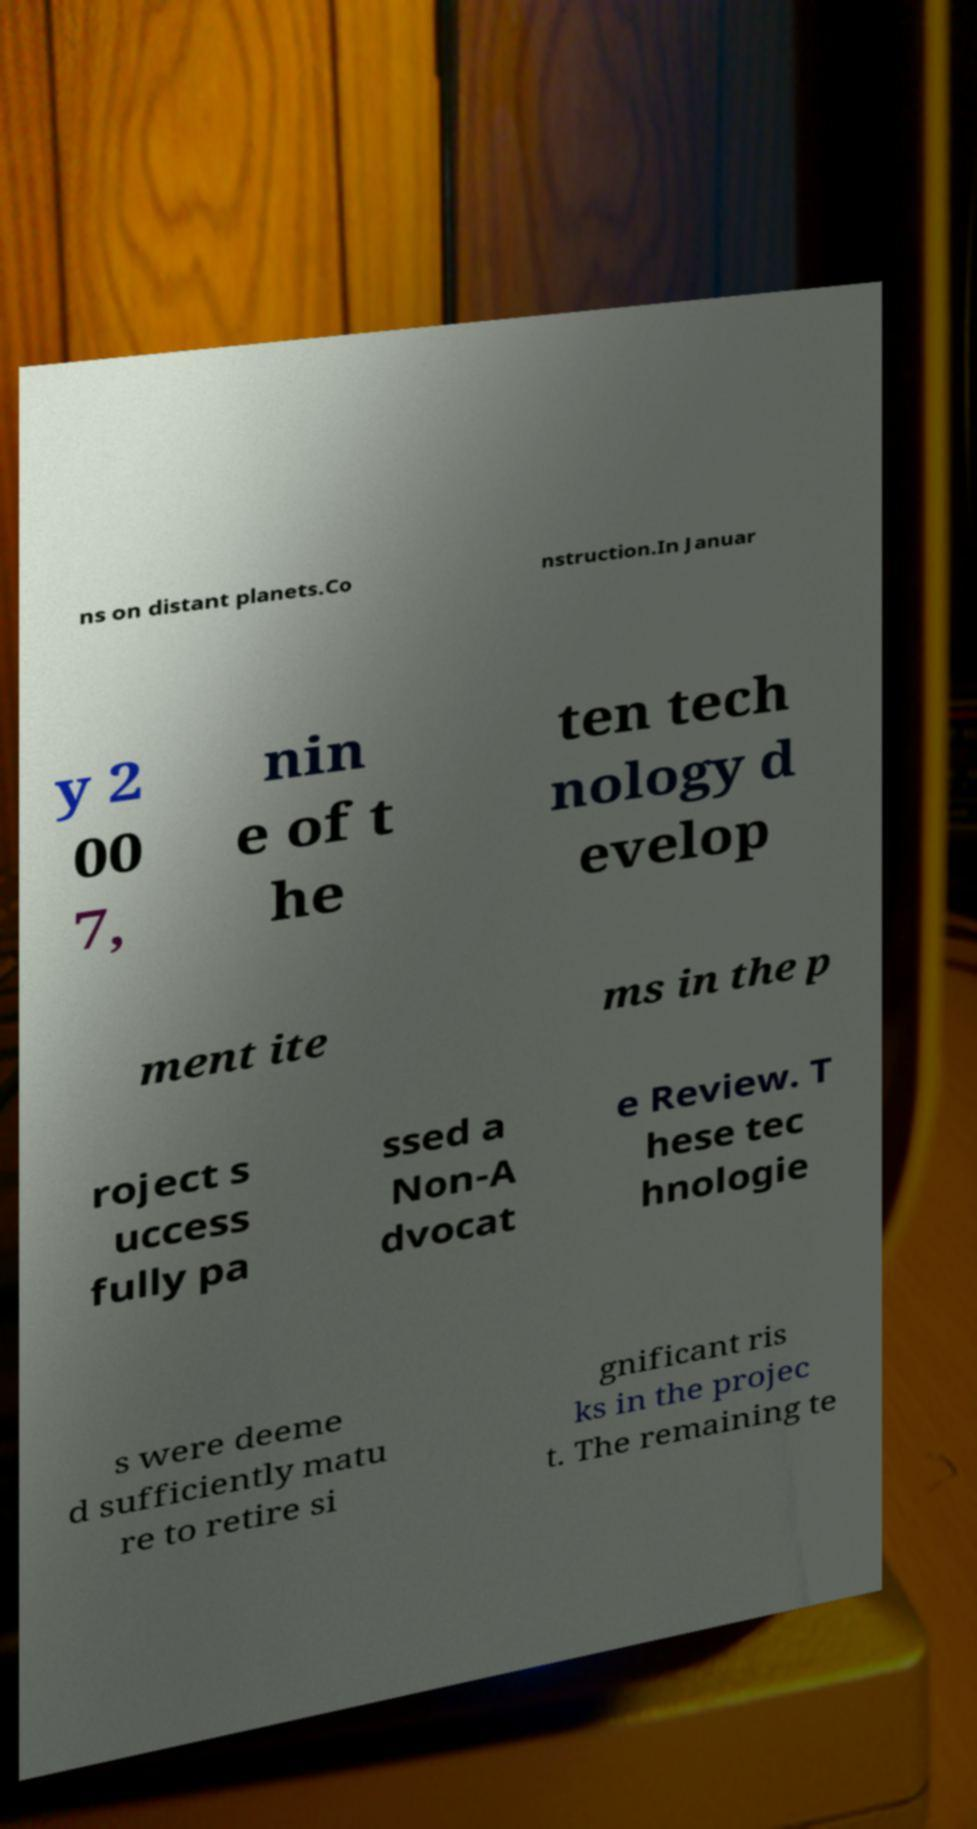There's text embedded in this image that I need extracted. Can you transcribe it verbatim? ns on distant planets.Co nstruction.In Januar y 2 00 7, nin e of t he ten tech nology d evelop ment ite ms in the p roject s uccess fully pa ssed a Non-A dvocat e Review. T hese tec hnologie s were deeme d sufficiently matu re to retire si gnificant ris ks in the projec t. The remaining te 